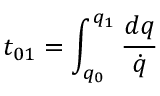Convert formula to latex. <formula><loc_0><loc_0><loc_500><loc_500>t _ { 0 1 } = \int _ { q _ { 0 } } ^ { q _ { 1 } } { \frac { d q } { \dot { q } } }</formula> 